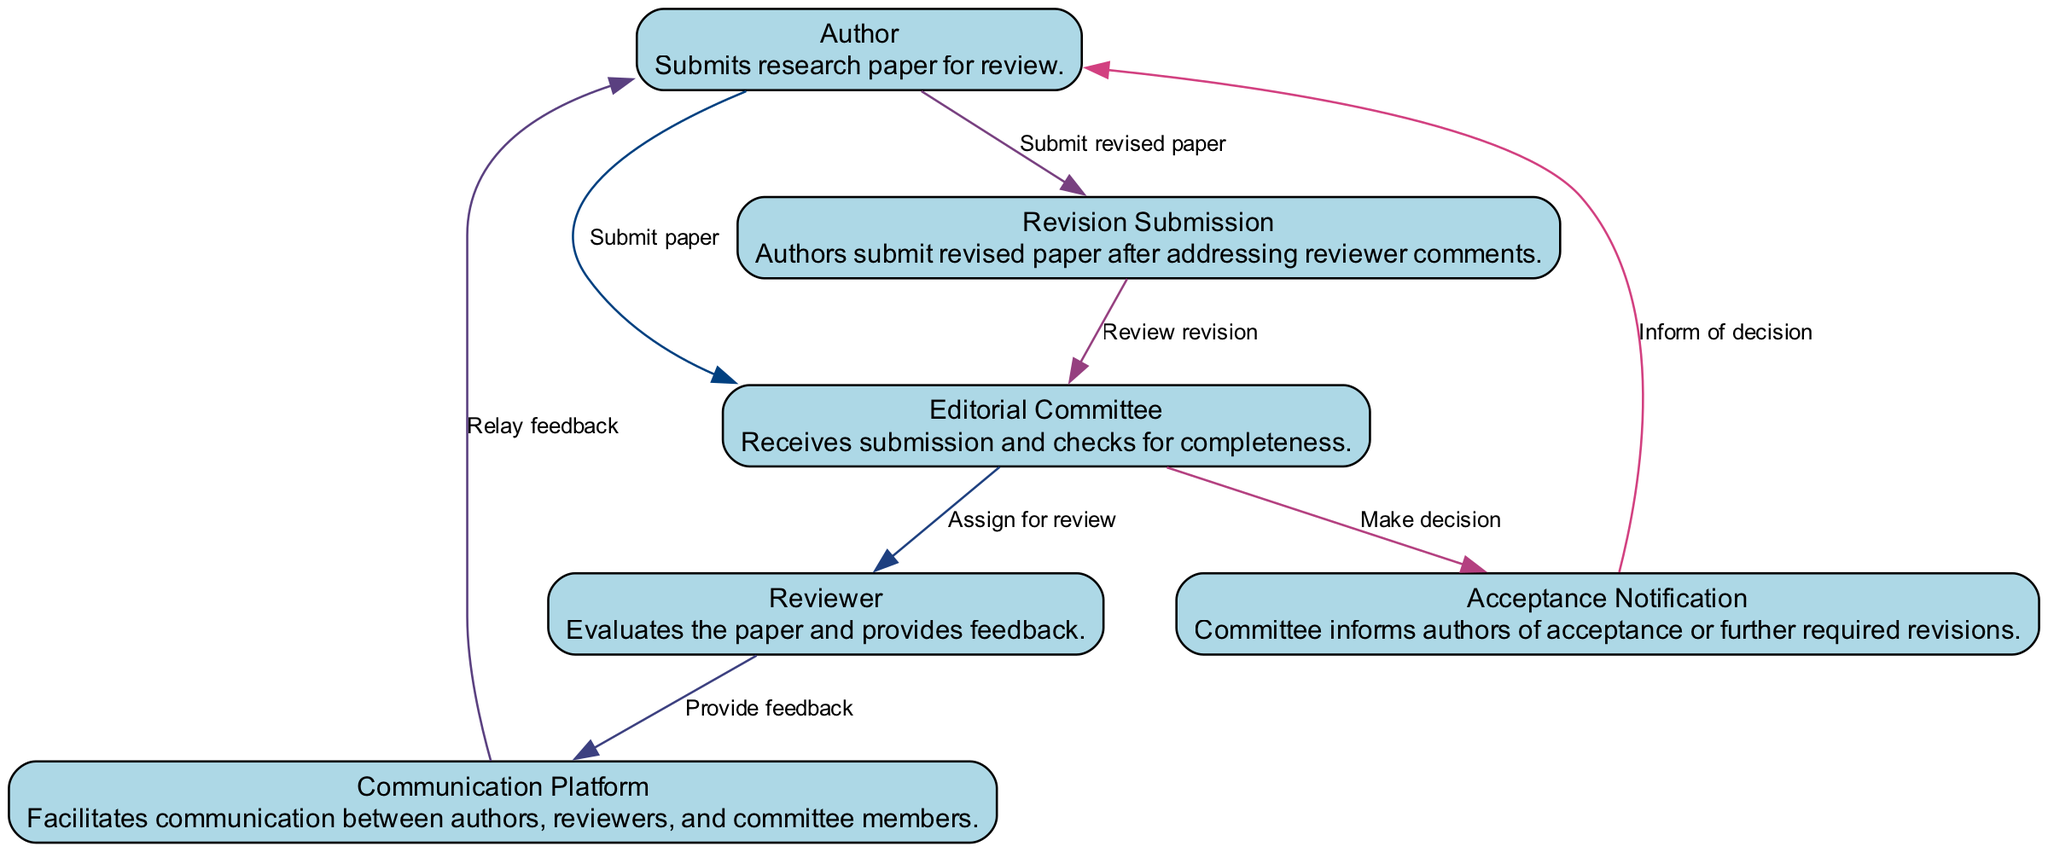What is the role of the Editorial Committee? The Editorial Committee receives the submission of the research paper and checks for its completeness.
Answer: Receives submission and checks for completeness How many entities are involved in the workflow? There are a total of six entities represented in the diagram: Author, Editorial Committee, Reviewer, Communication Platform, Revision Submission, and Acceptance Notification.
Answer: Six Who provides feedback on the submitted paper? The Reviewer evaluates the paper and provides feedback to the corresponding platform.
Answer: Reviewer What happens after the Author submits a revised paper? After submission, the Revision Submission communicates with the Editorial Committee to review the revision, indicating the next step in the process.
Answer: Review revision In which order does the Author interact with the Editorial Committee? The Author first submits the paper, and later submits the revised paper, indicating two distinct interactions in chronological order with the Editorial Committee.
Answer: Submit paper, submit revised paper Which entity relays feedback to the Author? The Communication Platform is the entity that relays feedback from the Reviewer to the Author in the workflow.
Answer: Communication Platform What action follows the acceptance notification? After the decision is made by the Editorial Committee, they inform the Author about its acceptance or required additional revisions.
Answer: Inform of decision Which two entities are directly connected by the action "Assign for review"? The Editorial Committee assigns the paper to the Reviewer for evaluation, creating a direct connection and defining their interaction during the process.
Answer: Editorial Committee and Reviewer 